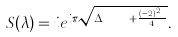Convert formula to latex. <formula><loc_0><loc_0><loc_500><loc_500>S ( \lambda ) = i e ^ { i \pi \sqrt { \Delta _ { \ p X } + \frac { ( n - 2 ) ^ { 2 } } { 4 } } } .</formula> 